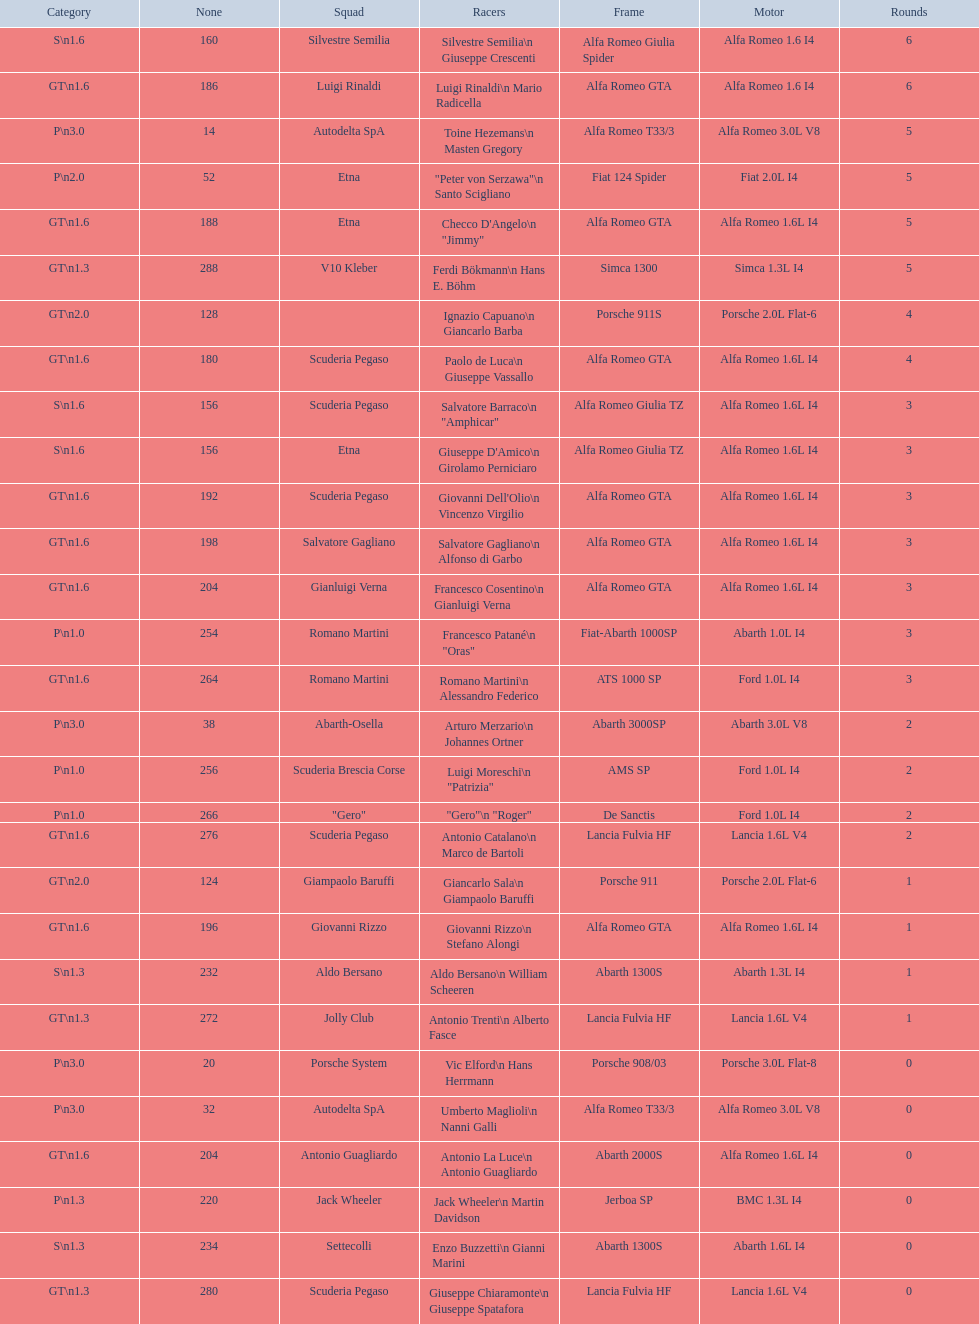Can you tell me the full name of the person who goes by the nickname "jimmy"? Checco D'Angelo. 